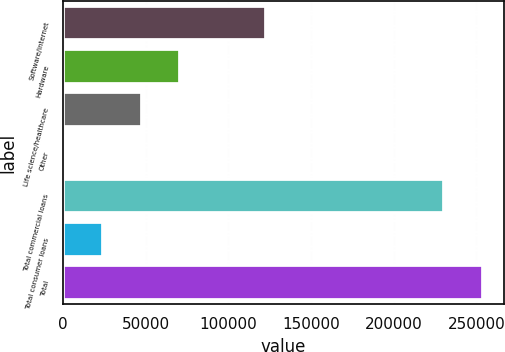Convert chart. <chart><loc_0><loc_0><loc_500><loc_500><bar_chart><fcel>Software/internet<fcel>Hardware<fcel>Life science/healthcare<fcel>Other<fcel>Total commercial loans<fcel>Total consumer loans<fcel>Total<nl><fcel>122748<fcel>70944.9<fcel>47585.6<fcel>867<fcel>230558<fcel>24226.3<fcel>253917<nl></chart> 